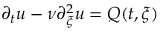Convert formula to latex. <formula><loc_0><loc_0><loc_500><loc_500>\partial _ { t } u - \nu \partial _ { \xi } ^ { 2 } u = Q ( t , \xi )</formula> 